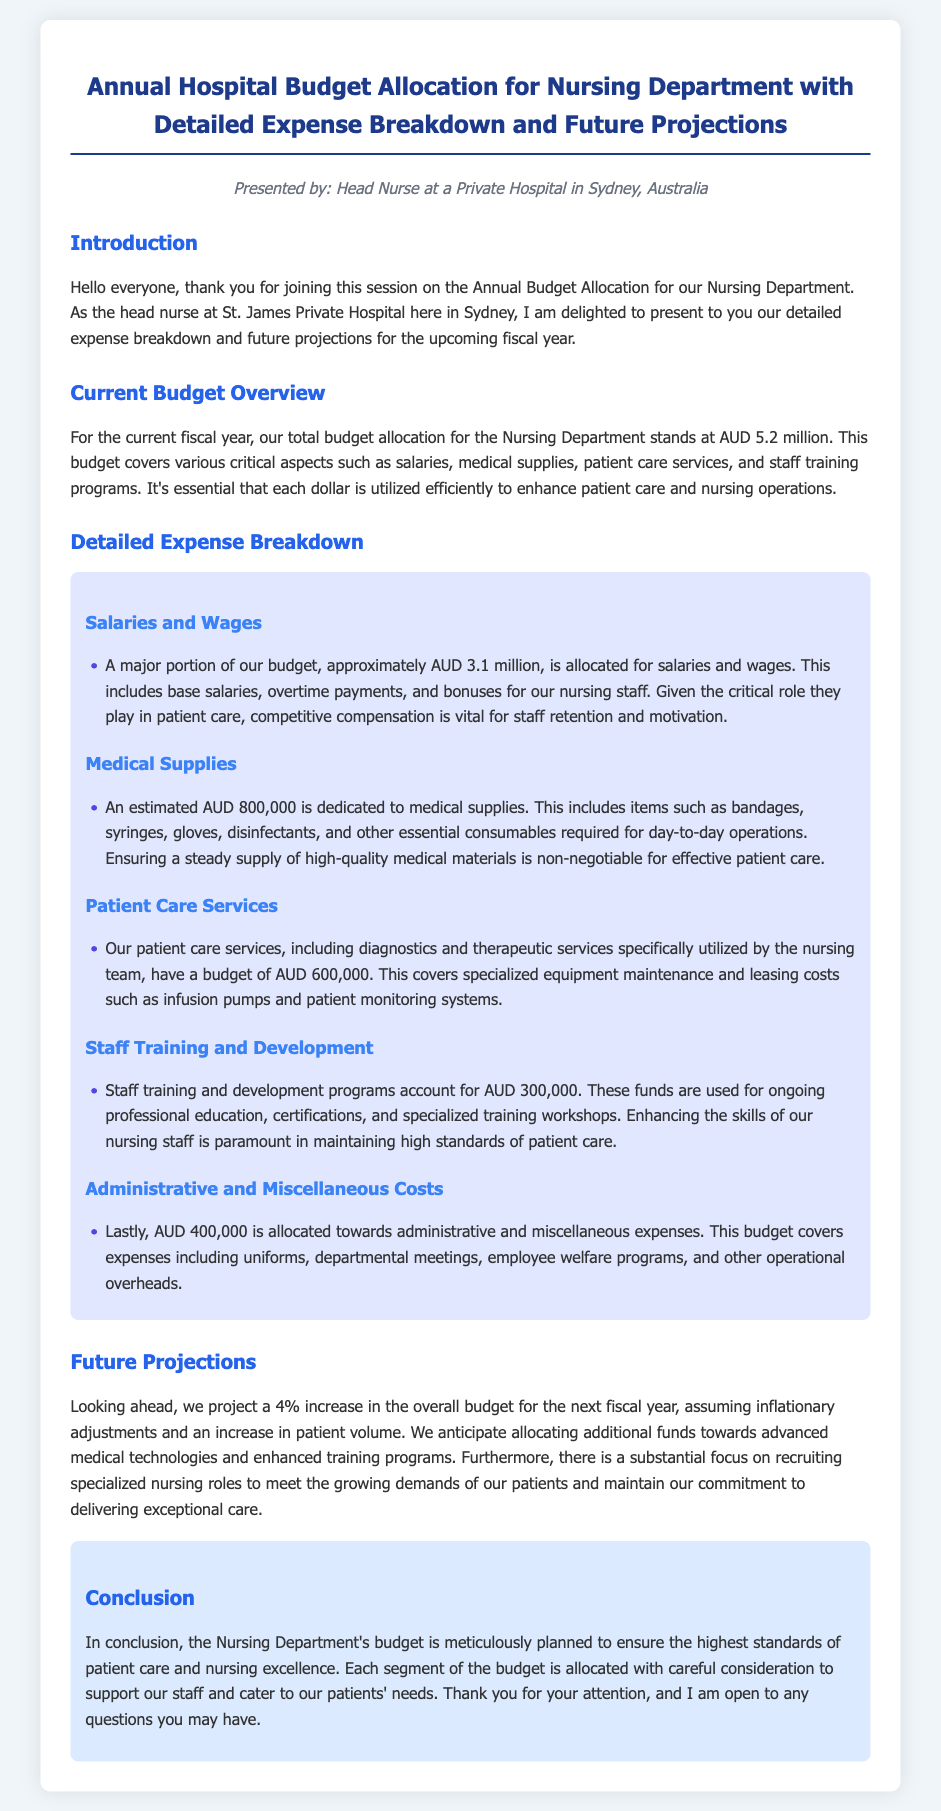What is the total budget allocation for the Nursing Department? The total budget allocation for the Nursing Department is specified as AUD 5.2 million.
Answer: AUD 5.2 million How much is allocated for salaries and wages? The document states that approximately AUD 3.1 million is allocated for salaries and wages.
Answer: AUD 3.1 million What percentage increase is projected for the next fiscal year? The document mentions a 4% increase in the budget for the next fiscal year.
Answer: 4% What is the budget for medical supplies? The budget allocated for medical supplies is mentioned as AUD 800,000 in the document.
Answer: AUD 800,000 What category accounts for AUD 300,000 in the budget? The budget for staff training and development programs accounts for AUD 300,000 as stated in the document.
Answer: Staff training and development Which expense covers specialized equipment maintenance? The expense for patient care services, covering specialized equipment maintenance, is detailed as AUD 600,000.
Answer: AUD 600,000 What is one of the anticipated purposes for additional funds next fiscal year? The document highlights that additional funds may be allocated towards advanced medical technologies.
Answer: Advanced medical technologies What is included in the administrative and miscellaneous costs? The document specifies that the AUD 400,000 allocated towards administrative and miscellaneous costs covers uniforms and employee welfare programs.
Answer: Uniforms and employee welfare programs What role does competitive compensation play according to the document? Competitive compensation is emphasized as vital for staff retention and motivation in the Nursing Department.
Answer: Staff retention and motivation How many categories are detailed in the expense breakdown? The document outlines five different categories in the detailed expense breakdown.
Answer: Five categories 